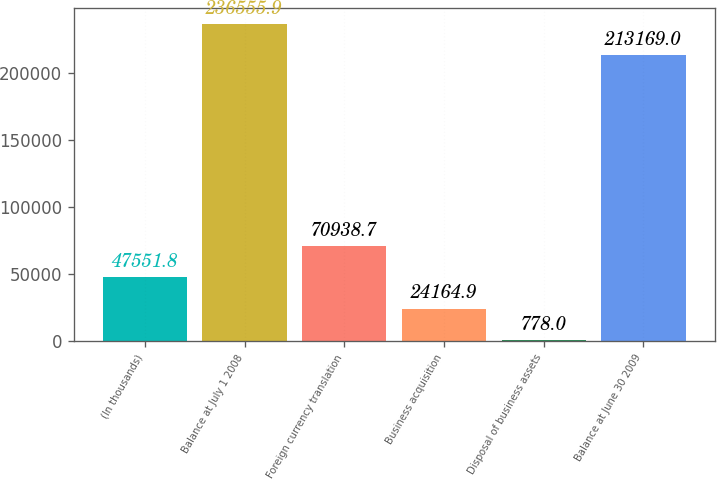Convert chart to OTSL. <chart><loc_0><loc_0><loc_500><loc_500><bar_chart><fcel>(In thousands)<fcel>Balance at July 1 2008<fcel>Foreign currency translation<fcel>Business acquisition<fcel>Disposal of business assets<fcel>Balance at June 30 2009<nl><fcel>47551.8<fcel>236556<fcel>70938.7<fcel>24164.9<fcel>778<fcel>213169<nl></chart> 